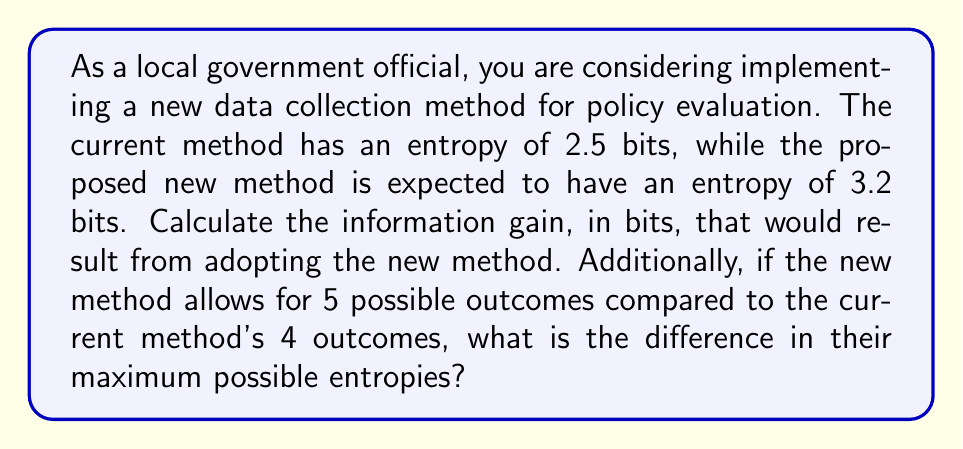What is the answer to this math problem? To solve this problem, we need to understand two key concepts from information theory: information gain and entropy.

1. Information Gain:
Information gain is the difference in entropy between two states or methods. In this case, it's the difference between the entropy of the new method and the current method.

Information Gain = $H_{new} - H_{current}$

Where $H$ represents the entropy of each method.

Information Gain = $3.2 - 2.5 = 0.7$ bits

2. Maximum Entropy:
The maximum possible entropy for a system with $n$ equally likely outcomes is given by:

$H_{max} = \log_2(n)$

For the current method with 4 possible outcomes:
$H_{max,current} = \log_2(4) = 2$ bits

For the new method with 5 possible outcomes:
$H_{max,new} = \log_2(5) \approx 2.322$ bits

The difference in maximum possible entropies:
$\Delta H_{max} = H_{max,new} - H_{max,current} = 2.322 - 2 = 0.322$ bits
Answer: The information gain from adopting the new method is 0.7 bits. The difference in maximum possible entropies between the new and current methods is approximately 0.322 bits. 